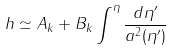Convert formula to latex. <formula><loc_0><loc_0><loc_500><loc_500>h \simeq A _ { k } + B _ { k } \int ^ { \eta } \frac { d \eta ^ { \prime } } { a ^ { 2 } ( \eta ^ { \prime } ) }</formula> 